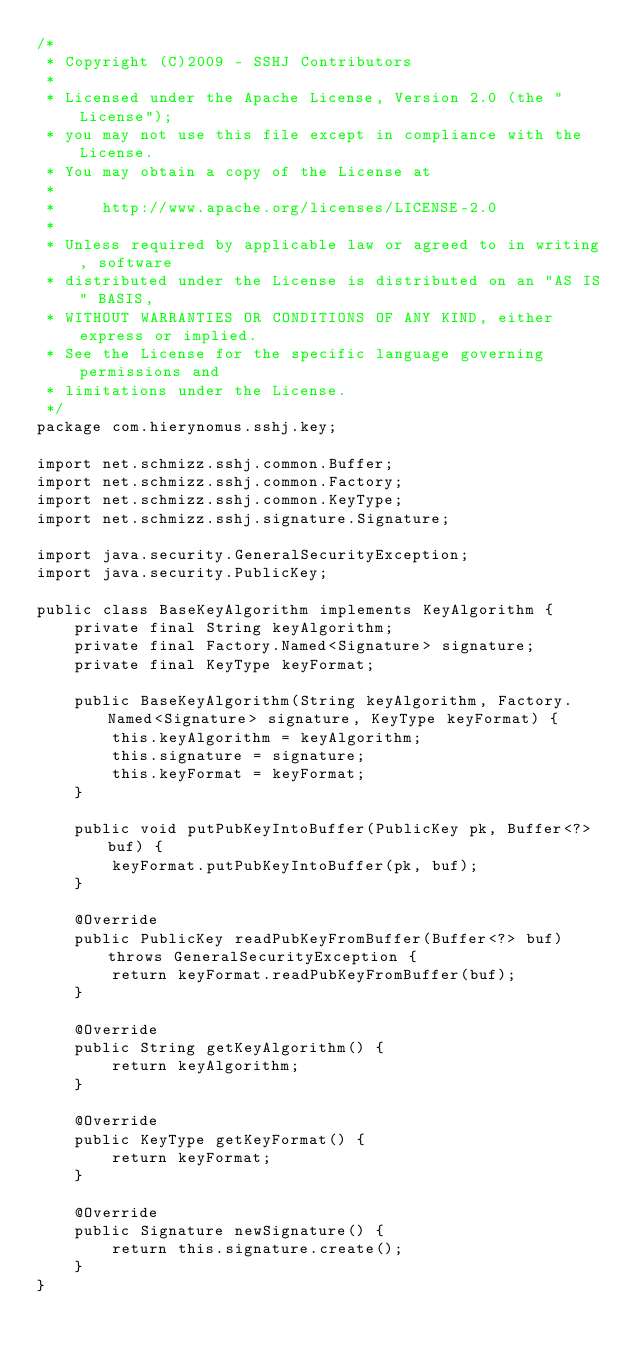<code> <loc_0><loc_0><loc_500><loc_500><_Java_>/*
 * Copyright (C)2009 - SSHJ Contributors
 *
 * Licensed under the Apache License, Version 2.0 (the "License");
 * you may not use this file except in compliance with the License.
 * You may obtain a copy of the License at
 *
 *     http://www.apache.org/licenses/LICENSE-2.0
 *
 * Unless required by applicable law or agreed to in writing, software
 * distributed under the License is distributed on an "AS IS" BASIS,
 * WITHOUT WARRANTIES OR CONDITIONS OF ANY KIND, either express or implied.
 * See the License for the specific language governing permissions and
 * limitations under the License.
 */
package com.hierynomus.sshj.key;

import net.schmizz.sshj.common.Buffer;
import net.schmizz.sshj.common.Factory;
import net.schmizz.sshj.common.KeyType;
import net.schmizz.sshj.signature.Signature;

import java.security.GeneralSecurityException;
import java.security.PublicKey;

public class BaseKeyAlgorithm implements KeyAlgorithm {
    private final String keyAlgorithm;
    private final Factory.Named<Signature> signature;
    private final KeyType keyFormat;

    public BaseKeyAlgorithm(String keyAlgorithm, Factory.Named<Signature> signature, KeyType keyFormat) {
        this.keyAlgorithm = keyAlgorithm;
        this.signature = signature;
        this.keyFormat = keyFormat;
    }

    public void putPubKeyIntoBuffer(PublicKey pk, Buffer<?> buf) {
        keyFormat.putPubKeyIntoBuffer(pk, buf);
    }

    @Override
    public PublicKey readPubKeyFromBuffer(Buffer<?> buf) throws GeneralSecurityException {
        return keyFormat.readPubKeyFromBuffer(buf);
    }

    @Override
    public String getKeyAlgorithm() {
        return keyAlgorithm;
    }

    @Override
    public KeyType getKeyFormat() {
        return keyFormat;
    }

    @Override
    public Signature newSignature() {
        return this.signature.create();
    }
}
</code> 